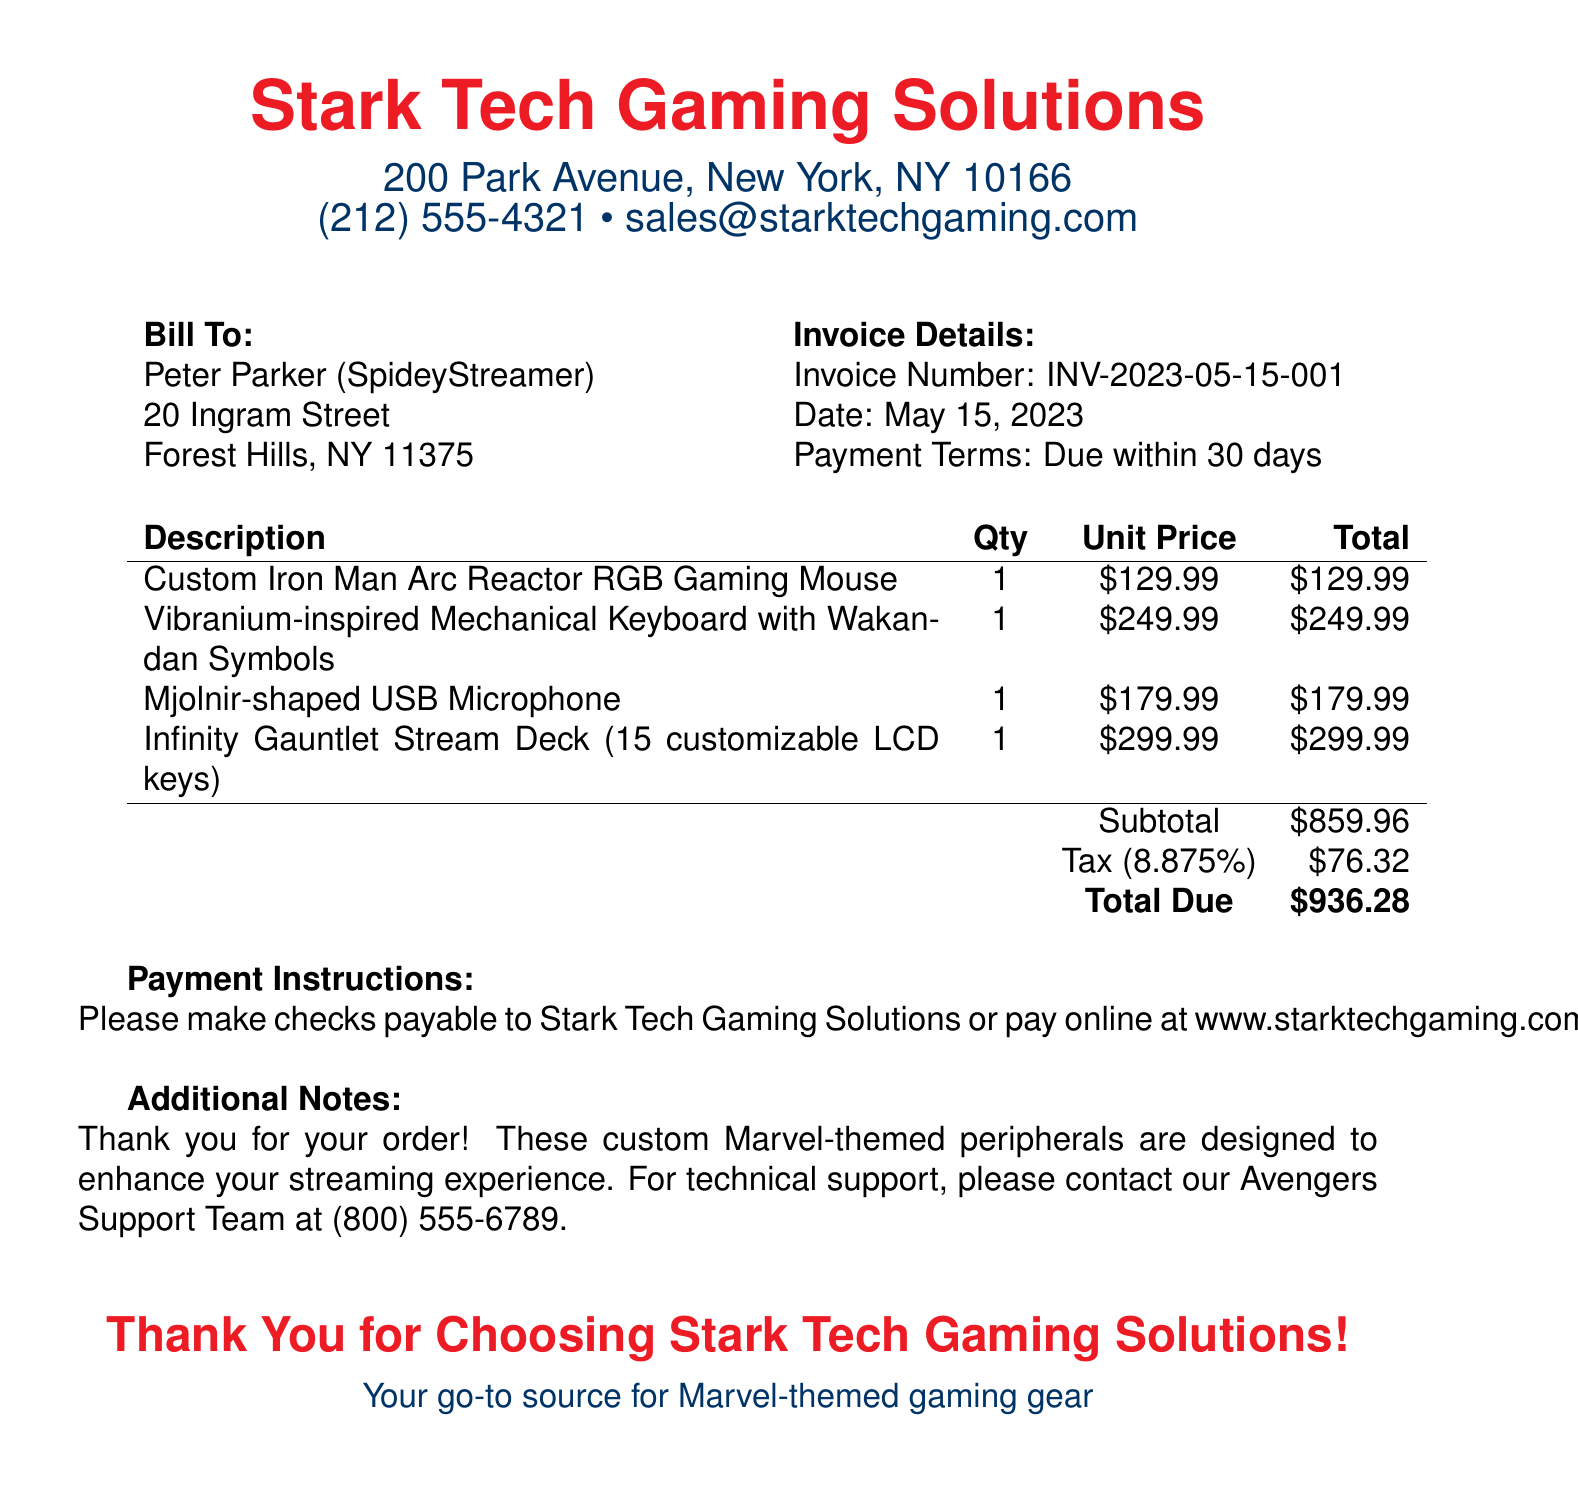what is the invoice number? The invoice number is specifically stated under the invoice details section in the document.
Answer: INV-2023-05-15-001 who is the bill to? The document specifies the name of the person being billed, which is mentioned at the top of the billing section.
Answer: Peter Parker (SpideyStreamer) what is the total due? The total due is calculated at the end of the invoice, summarizing the total costs.
Answer: $936.28 what is the payment term? The payment terms are mentioned in the invoice details section, indicating when the payment is due.
Answer: Due within 30 days how much does the Infinity Gauntlet Stream Deck cost? The cost of the specific item is listed in the itemized section of the invoice.
Answer: $299.99 what is the subtotal amount before tax? The subtotal is shown as a separate line item before tax is applied in the total calculation.
Answer: $859.96 what is the tax rate applied? The tax rate is mentioned in parentheses beside the tax amount in the invoice.
Answer: 8.875% where should the checks be payable? The payment instructions specify explicitly where checks should be made payable.
Answer: Stark Tech Gaming Solutions how can one pay online? The document provides a specific web address for payment, indicating how to pay online.
Answer: www.starktechgaming.com/pay 